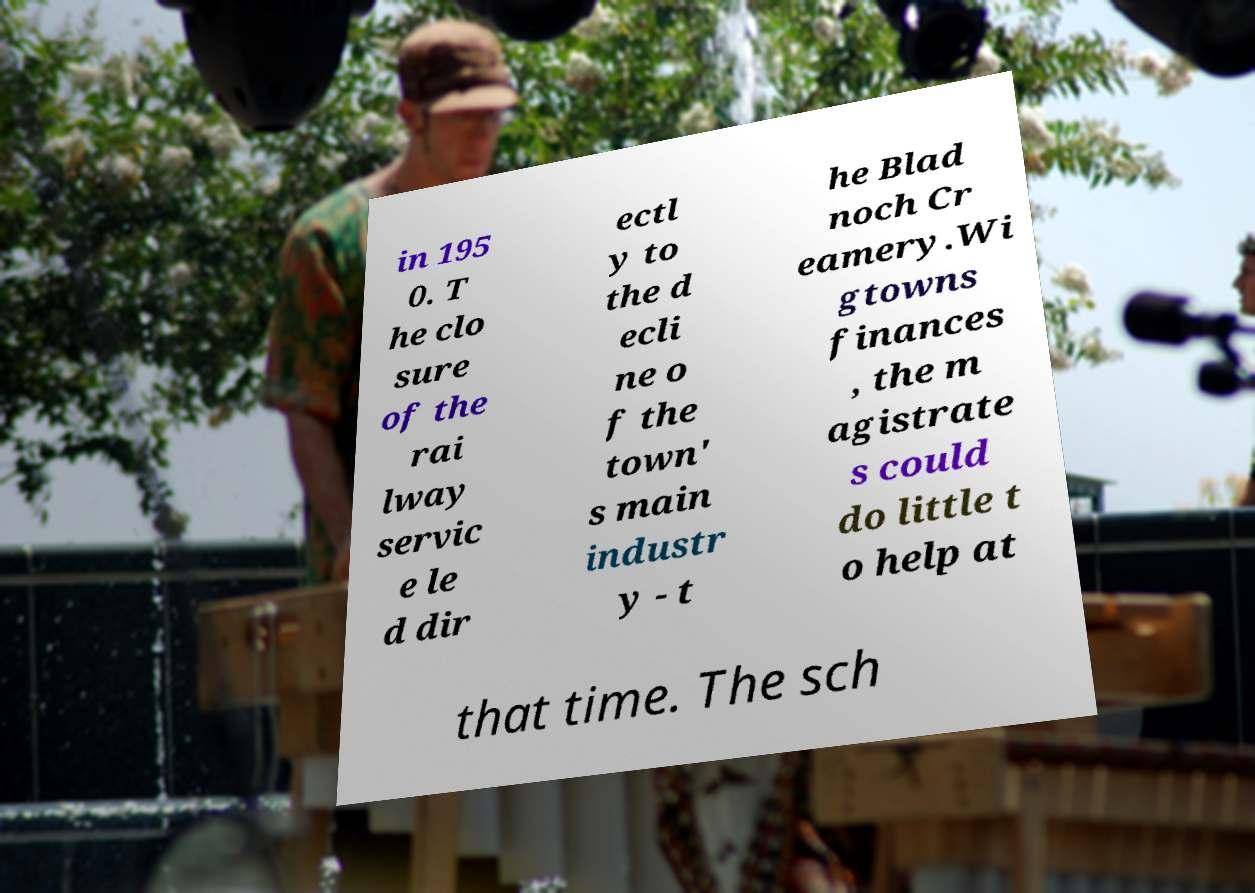Please read and relay the text visible in this image. What does it say? in 195 0. T he clo sure of the rai lway servic e le d dir ectl y to the d ecli ne o f the town' s main industr y - t he Blad noch Cr eamery.Wi gtowns finances , the m agistrate s could do little t o help at that time. The sch 